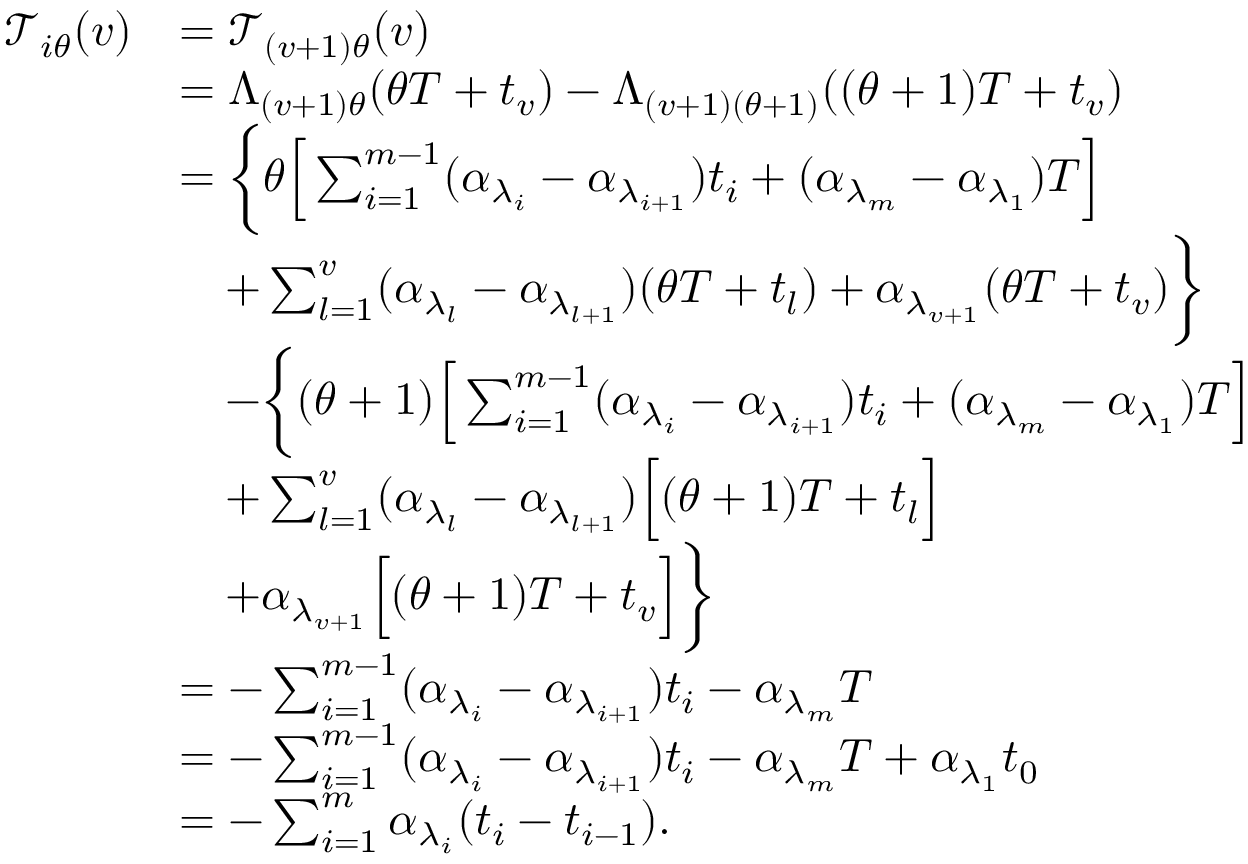Convert formula to latex. <formula><loc_0><loc_0><loc_500><loc_500>\begin{array} { r l } { \mathcal { T } _ { i \theta } ( v ) } & { = \mathcal { T } _ { ( v + 1 ) \theta } ( v ) } \\ & { = \Lambda _ { ( v + 1 ) \theta } ( \theta T + t _ { v } ) - \Lambda _ { ( v + 1 ) ( \theta + 1 ) } ( ( \theta + 1 ) T + t _ { v } ) } \\ & { = \left \{ \theta \left [ \sum _ { i = 1 } ^ { m - 1 } ( \alpha _ { \lambda _ { i } } - \alpha _ { \lambda _ { i + 1 } } ) t _ { i } + ( \alpha _ { \lambda _ { m } } - \alpha _ { \lambda _ { 1 } } ) T \right ] } \\ & { \quad + \sum _ { l = 1 } ^ { v } ( \alpha _ { \lambda _ { l } } - \alpha _ { \lambda _ { l + 1 } } ) ( \theta T + t _ { l } ) + \alpha _ { \lambda _ { v + 1 } } ( \theta T + t _ { v } ) \right \} } \\ & { \quad - \left \{ ( \theta + 1 ) \left [ \sum _ { i = 1 } ^ { m - 1 } ( \alpha _ { \lambda _ { i } } - \alpha _ { \lambda _ { i + 1 } } ) t _ { i } + ( \alpha _ { \lambda _ { m } } - \alpha _ { \lambda _ { 1 } } ) T \right ] } \\ & { \quad + \sum _ { l = 1 } ^ { v } ( \alpha _ { \lambda _ { l } } - \alpha _ { \lambda _ { l + 1 } } ) \left [ ( \theta + 1 ) T + t _ { l } \right ] } \\ & { \quad + \alpha _ { \lambda _ { v + 1 } } \left [ ( \theta + 1 ) T + t _ { v } \right ] \right \} } \\ & { = - \sum _ { i = 1 } ^ { m - 1 } ( \alpha _ { \lambda _ { i } } - \alpha _ { \lambda _ { i + 1 } } ) t _ { i } - \alpha _ { \lambda _ { m } } T } \\ & { = - \sum _ { i = 1 } ^ { m - 1 } ( \alpha _ { \lambda _ { i } } - \alpha _ { \lambda _ { i + 1 } } ) t _ { i } - \alpha _ { \lambda _ { m } } T + \alpha _ { \lambda _ { 1 } } t _ { 0 } } \\ & { = - \sum _ { i = 1 } ^ { m } \alpha _ { \lambda _ { i } } ( t _ { i } - t _ { i - 1 } ) . } \end{array}</formula> 